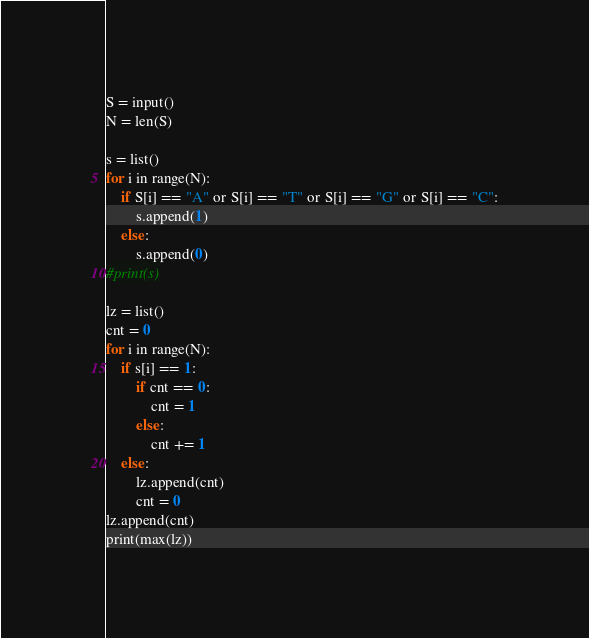<code> <loc_0><loc_0><loc_500><loc_500><_Python_>S = input()
N = len(S)

s = list()
for i in range(N):
    if S[i] == "A" or S[i] == "T" or S[i] == "G" or S[i] == "C":
        s.append(1)
    else:
        s.append(0)
#print(s)

lz = list()
cnt = 0
for i in range(N):
    if s[i] == 1:
        if cnt == 0:
            cnt = 1
        else:
            cnt += 1
    else:
        lz.append(cnt)
        cnt = 0
lz.append(cnt)
print(max(lz))</code> 